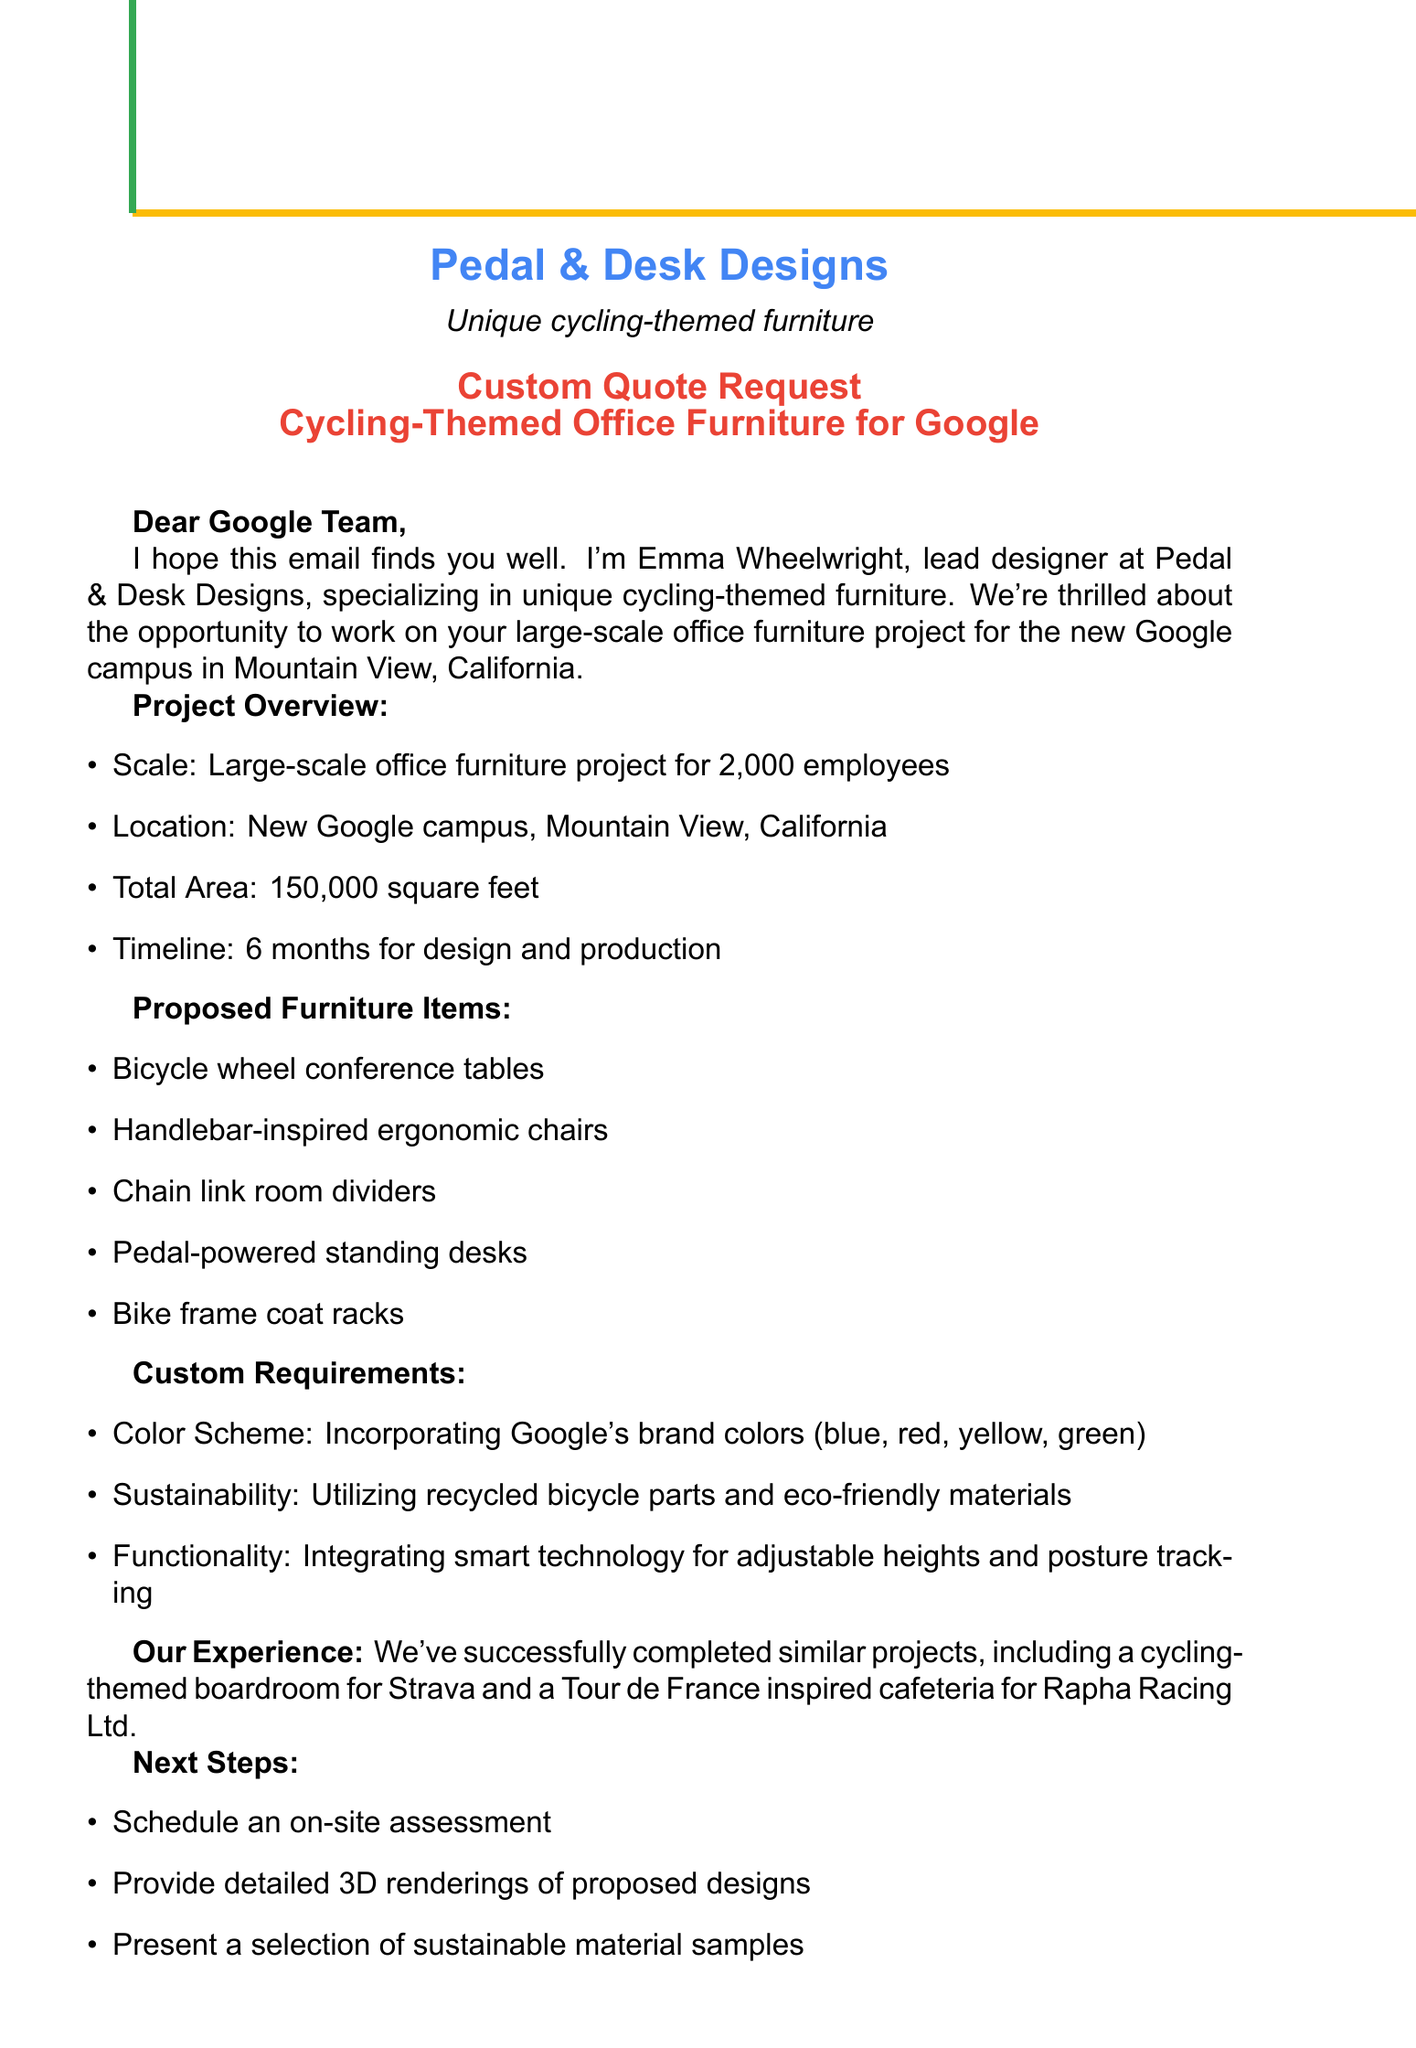what is the company name? The company name is mentioned in the introduction section of the document.
Answer: Pedal & Desk Designs who is the designer? The designer's name is provided in the introduction of the email.
Answer: Emma Wheelwright how many employees will the furniture serve? The number of employees is specified in the project scope section.
Answer: 2000 what is the total square footage of the project? The total area for the office furniture project is detailed in the project scope.
Answer: 150000 what type of furniture item is inspired by handlebars? The document lists specific furniture items in the proposed section.
Answer: Handlebar-inspired ergonomic chairs what is the timeline for design and production? The timeline for the project's design and production can be found in the project scope section.
Answer: 6 months which company had a cycling-themed boardroom designed? A previous relevant project mentioned in the document provides the name of the company.
Answer: Strava what is the proposed color scheme? The document outlines the custom requirements, highlighting the desired color scheme.
Answer: Google's brand colors what will be included in the next steps? The next steps detail actions mentioned to proceed with the project, found in the next steps section.
Answer: Schedule an on-site assessment what type of call is being requested? The call to action describes the desired communication method with the client.
Answer: Video call 